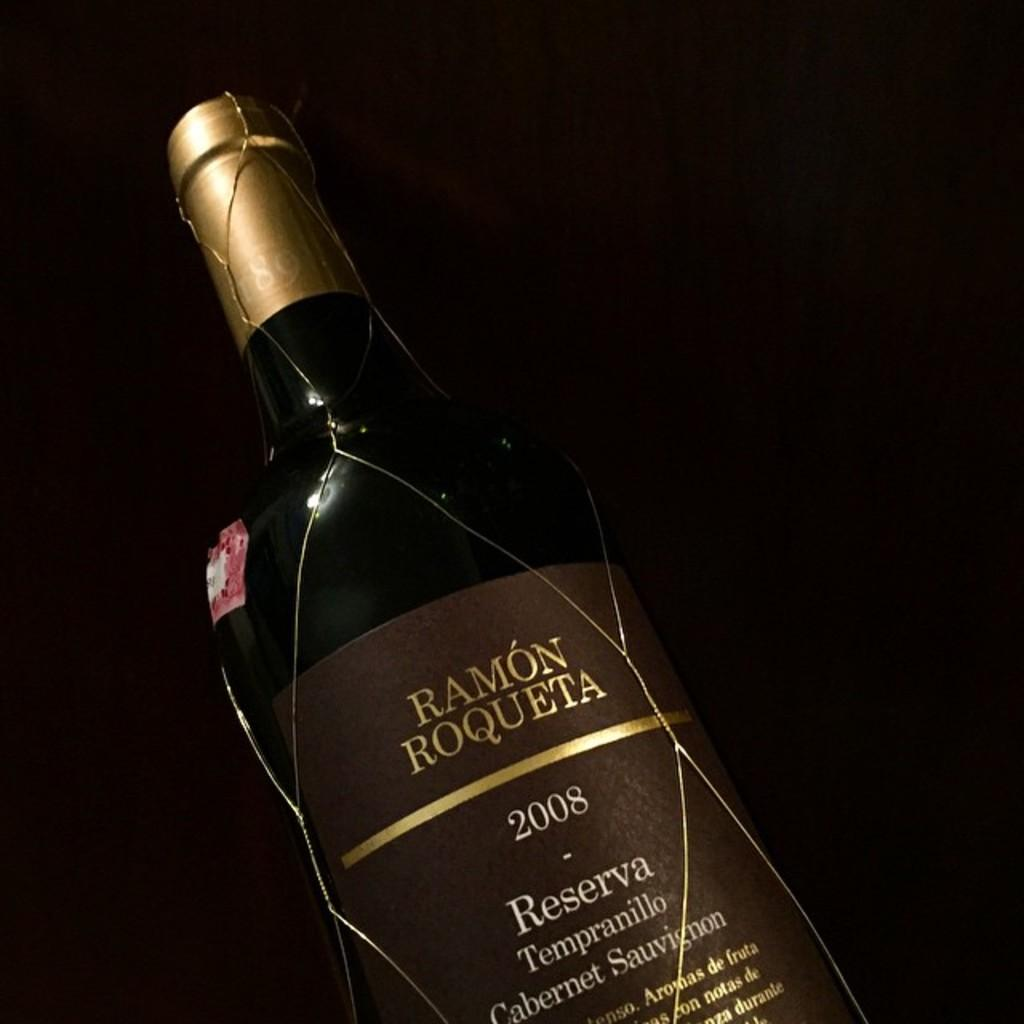<image>
Create a compact narrative representing the image presented. Bottle with a brown label that says "Ramon Roqueta" on it. 